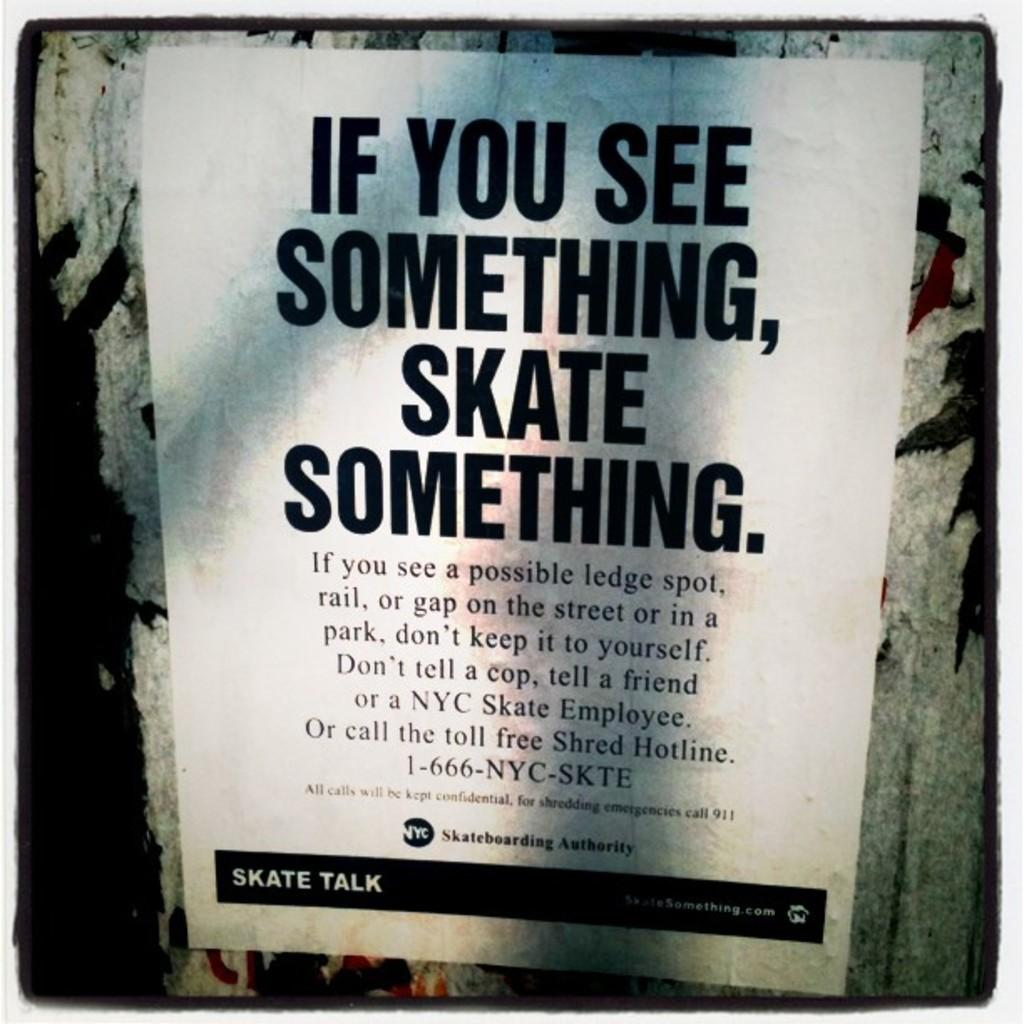<image>
Write a terse but informative summary of the picture. A black and white poster supporting Skating, and sharing of rails, and ledge spots seen. 